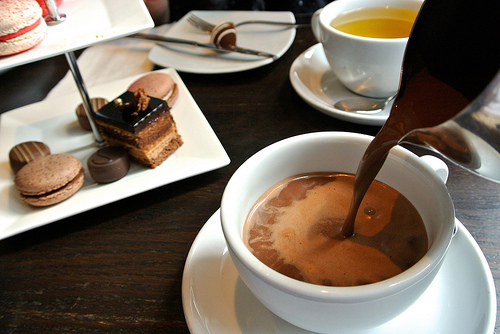<image>
Can you confirm if the mug is next to the plate? No. The mug is not positioned next to the plate. They are located in different areas of the scene. Is the cocoa in the chocolate? Yes. The cocoa is contained within or inside the chocolate, showing a containment relationship. 